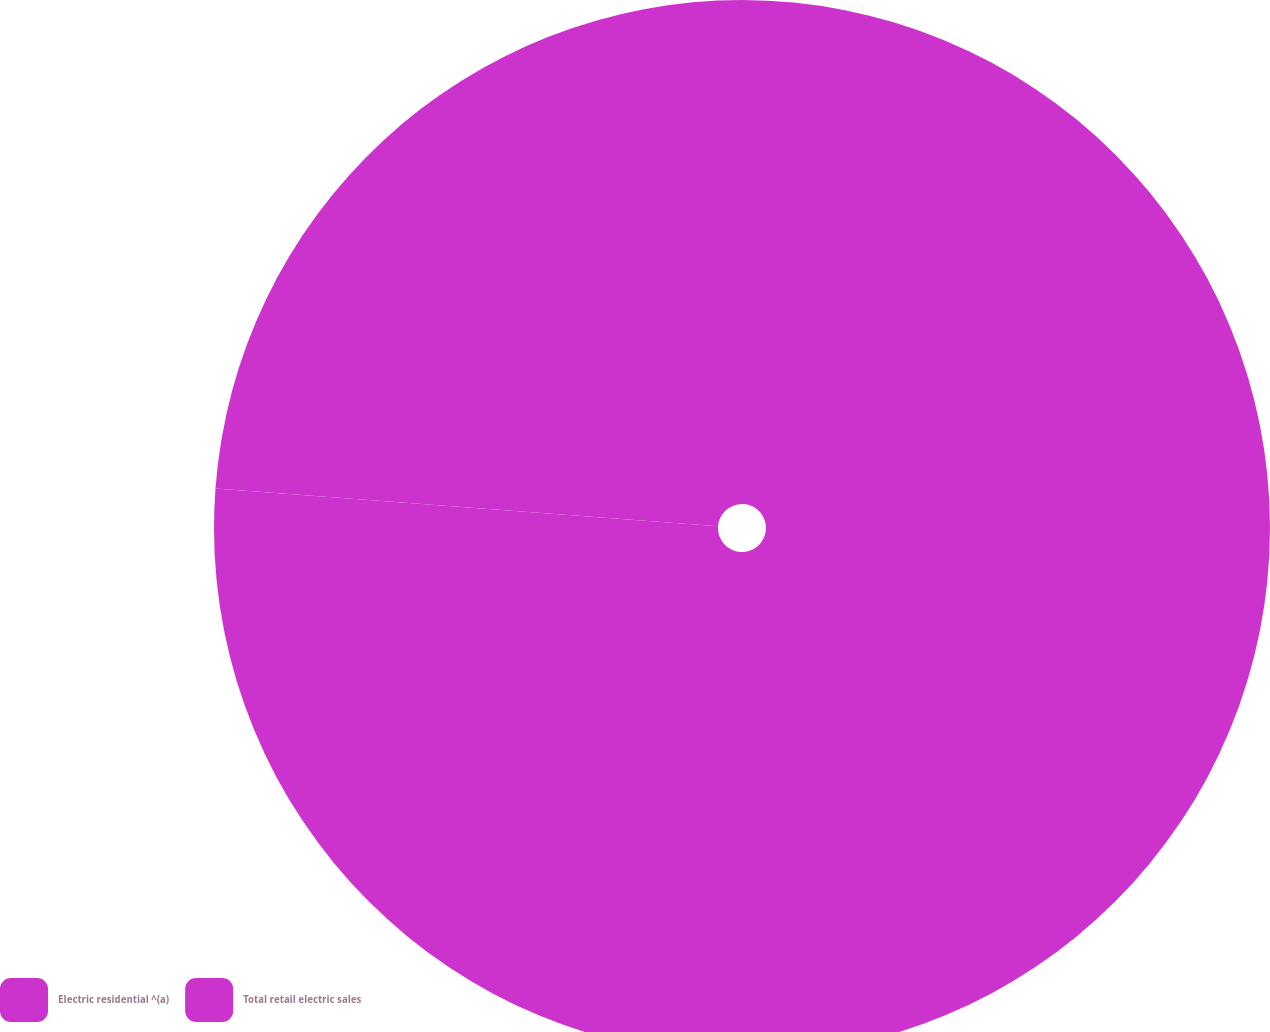Convert chart to OTSL. <chart><loc_0><loc_0><loc_500><loc_500><pie_chart><fcel>Electric residential ^(a)<fcel>Total retail electric sales<nl><fcel>76.19%<fcel>23.81%<nl></chart> 